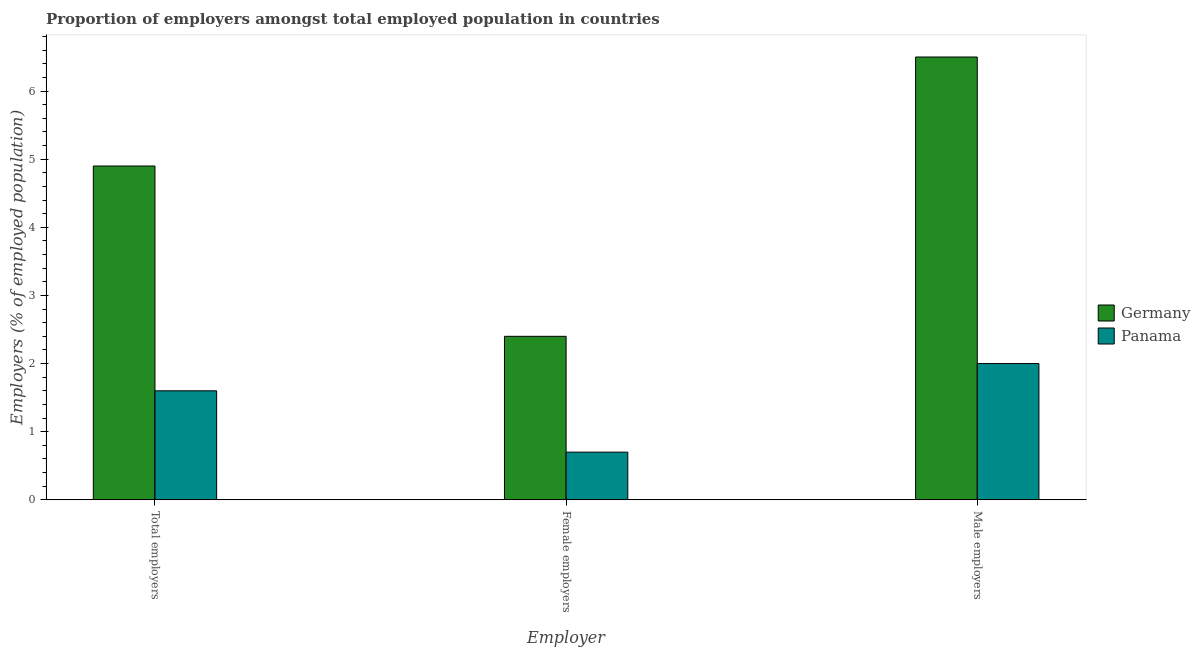How many groups of bars are there?
Your response must be concise. 3. Are the number of bars on each tick of the X-axis equal?
Keep it short and to the point. Yes. How many bars are there on the 1st tick from the left?
Your answer should be compact. 2. How many bars are there on the 2nd tick from the right?
Offer a very short reply. 2. What is the label of the 3rd group of bars from the left?
Give a very brief answer. Male employers. Across all countries, what is the maximum percentage of male employers?
Keep it short and to the point. 6.5. Across all countries, what is the minimum percentage of female employers?
Offer a very short reply. 0.7. In which country was the percentage of female employers minimum?
Make the answer very short. Panama. What is the total percentage of female employers in the graph?
Make the answer very short. 3.1. What is the difference between the percentage of male employers in Germany and that in Panama?
Your response must be concise. 4.5. What is the difference between the percentage of total employers in Panama and the percentage of female employers in Germany?
Provide a succinct answer. -0.8. What is the average percentage of total employers per country?
Your response must be concise. 3.25. What is the difference between the percentage of male employers and percentage of female employers in Panama?
Provide a short and direct response. 1.3. What is the ratio of the percentage of male employers in Panama to that in Germany?
Provide a short and direct response. 0.31. Is the difference between the percentage of female employers in Panama and Germany greater than the difference between the percentage of total employers in Panama and Germany?
Your answer should be compact. Yes. What is the difference between the highest and the second highest percentage of female employers?
Your answer should be very brief. 1.7. What is the difference between the highest and the lowest percentage of total employers?
Keep it short and to the point. 3.3. In how many countries, is the percentage of total employers greater than the average percentage of total employers taken over all countries?
Offer a very short reply. 1. What does the 2nd bar from the right in Total employers represents?
Give a very brief answer. Germany. Is it the case that in every country, the sum of the percentage of total employers and percentage of female employers is greater than the percentage of male employers?
Your response must be concise. Yes. Are all the bars in the graph horizontal?
Offer a very short reply. No. How many countries are there in the graph?
Ensure brevity in your answer.  2. What is the difference between two consecutive major ticks on the Y-axis?
Offer a terse response. 1. Are the values on the major ticks of Y-axis written in scientific E-notation?
Your answer should be very brief. No. Where does the legend appear in the graph?
Keep it short and to the point. Center right. What is the title of the graph?
Give a very brief answer. Proportion of employers amongst total employed population in countries. What is the label or title of the X-axis?
Offer a terse response. Employer. What is the label or title of the Y-axis?
Ensure brevity in your answer.  Employers (% of employed population). What is the Employers (% of employed population) in Germany in Total employers?
Make the answer very short. 4.9. What is the Employers (% of employed population) of Panama in Total employers?
Your response must be concise. 1.6. What is the Employers (% of employed population) of Germany in Female employers?
Offer a terse response. 2.4. What is the Employers (% of employed population) of Panama in Female employers?
Provide a short and direct response. 0.7. What is the Employers (% of employed population) in Germany in Male employers?
Offer a very short reply. 6.5. Across all Employer, what is the maximum Employers (% of employed population) in Germany?
Your answer should be very brief. 6.5. Across all Employer, what is the maximum Employers (% of employed population) in Panama?
Keep it short and to the point. 2. Across all Employer, what is the minimum Employers (% of employed population) of Germany?
Keep it short and to the point. 2.4. Across all Employer, what is the minimum Employers (% of employed population) of Panama?
Offer a terse response. 0.7. What is the total Employers (% of employed population) in Germany in the graph?
Your answer should be compact. 13.8. What is the total Employers (% of employed population) in Panama in the graph?
Offer a very short reply. 4.3. What is the difference between the Employers (% of employed population) in Germany in Total employers and that in Female employers?
Provide a short and direct response. 2.5. What is the average Employers (% of employed population) of Panama per Employer?
Keep it short and to the point. 1.43. What is the difference between the Employers (% of employed population) in Germany and Employers (% of employed population) in Panama in Male employers?
Offer a terse response. 4.5. What is the ratio of the Employers (% of employed population) of Germany in Total employers to that in Female employers?
Offer a terse response. 2.04. What is the ratio of the Employers (% of employed population) in Panama in Total employers to that in Female employers?
Ensure brevity in your answer.  2.29. What is the ratio of the Employers (% of employed population) of Germany in Total employers to that in Male employers?
Make the answer very short. 0.75. What is the ratio of the Employers (% of employed population) of Panama in Total employers to that in Male employers?
Your answer should be compact. 0.8. What is the ratio of the Employers (% of employed population) of Germany in Female employers to that in Male employers?
Provide a short and direct response. 0.37. What is the ratio of the Employers (% of employed population) in Panama in Female employers to that in Male employers?
Your answer should be compact. 0.35. What is the difference between the highest and the second highest Employers (% of employed population) of Germany?
Give a very brief answer. 1.6. What is the difference between the highest and the lowest Employers (% of employed population) of Germany?
Keep it short and to the point. 4.1. 